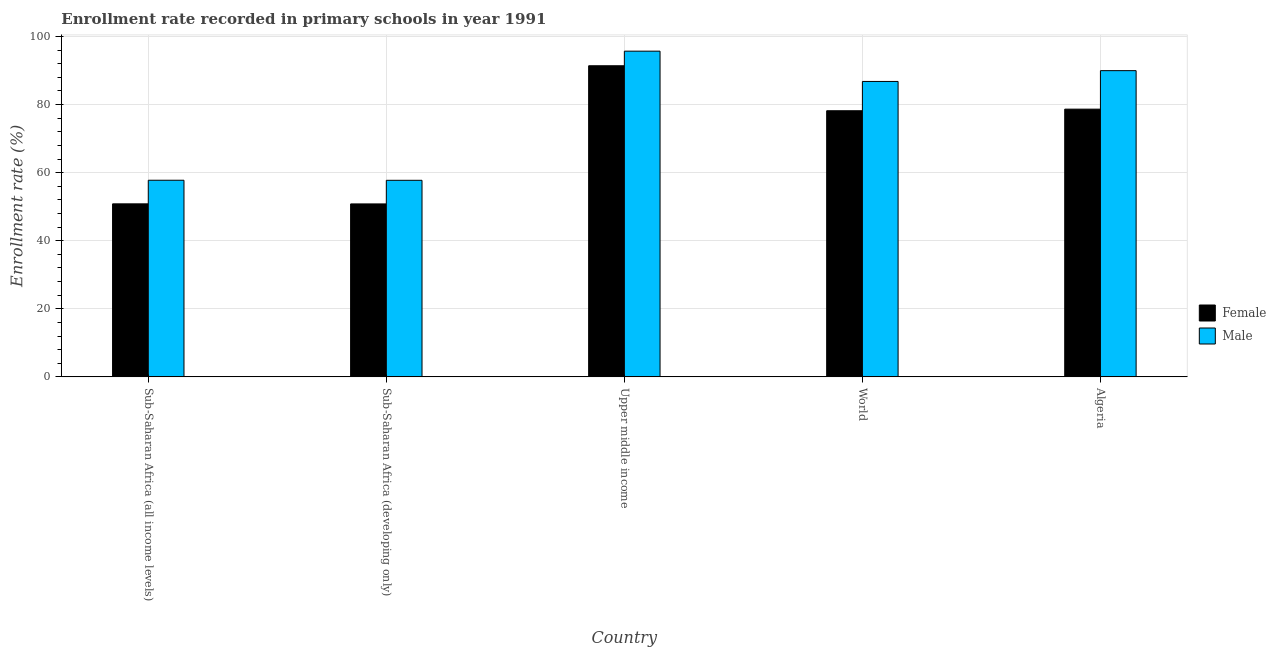How many different coloured bars are there?
Your answer should be compact. 2. Are the number of bars per tick equal to the number of legend labels?
Provide a short and direct response. Yes. Are the number of bars on each tick of the X-axis equal?
Your response must be concise. Yes. How many bars are there on the 4th tick from the left?
Ensure brevity in your answer.  2. What is the enrollment rate of male students in World?
Your answer should be very brief. 86.78. Across all countries, what is the maximum enrollment rate of male students?
Give a very brief answer. 95.68. Across all countries, what is the minimum enrollment rate of male students?
Provide a short and direct response. 57.74. In which country was the enrollment rate of female students maximum?
Offer a terse response. Upper middle income. In which country was the enrollment rate of female students minimum?
Your answer should be compact. Sub-Saharan Africa (developing only). What is the total enrollment rate of male students in the graph?
Offer a terse response. 387.91. What is the difference between the enrollment rate of male students in Algeria and that in Upper middle income?
Keep it short and to the point. -5.73. What is the difference between the enrollment rate of female students in Algeria and the enrollment rate of male students in Upper middle income?
Ensure brevity in your answer.  -17.03. What is the average enrollment rate of male students per country?
Your answer should be very brief. 77.58. What is the difference between the enrollment rate of male students and enrollment rate of female students in Sub-Saharan Africa (all income levels)?
Offer a terse response. 6.93. What is the ratio of the enrollment rate of female students in Algeria to that in Sub-Saharan Africa (all income levels)?
Give a very brief answer. 1.55. Is the enrollment rate of female students in Sub-Saharan Africa (developing only) less than that in World?
Offer a terse response. Yes. What is the difference between the highest and the second highest enrollment rate of female students?
Your answer should be very brief. 12.75. What is the difference between the highest and the lowest enrollment rate of female students?
Ensure brevity in your answer.  40.59. How many bars are there?
Your answer should be very brief. 10. Are all the bars in the graph horizontal?
Ensure brevity in your answer.  No. Does the graph contain any zero values?
Your response must be concise. No. Where does the legend appear in the graph?
Give a very brief answer. Center right. How are the legend labels stacked?
Offer a very short reply. Vertical. What is the title of the graph?
Your response must be concise. Enrollment rate recorded in primary schools in year 1991. Does "Private funds" appear as one of the legend labels in the graph?
Your response must be concise. No. What is the label or title of the Y-axis?
Provide a short and direct response. Enrollment rate (%). What is the Enrollment rate (%) in Female in Sub-Saharan Africa (all income levels)?
Your response must be concise. 50.83. What is the Enrollment rate (%) of Male in Sub-Saharan Africa (all income levels)?
Ensure brevity in your answer.  57.76. What is the Enrollment rate (%) in Female in Sub-Saharan Africa (developing only)?
Offer a terse response. 50.8. What is the Enrollment rate (%) of Male in Sub-Saharan Africa (developing only)?
Offer a very short reply. 57.74. What is the Enrollment rate (%) in Female in Upper middle income?
Ensure brevity in your answer.  91.39. What is the Enrollment rate (%) of Male in Upper middle income?
Your response must be concise. 95.68. What is the Enrollment rate (%) of Female in World?
Your response must be concise. 78.17. What is the Enrollment rate (%) of Male in World?
Your response must be concise. 86.78. What is the Enrollment rate (%) of Female in Algeria?
Your answer should be very brief. 78.64. What is the Enrollment rate (%) in Male in Algeria?
Make the answer very short. 89.95. Across all countries, what is the maximum Enrollment rate (%) of Female?
Your answer should be compact. 91.39. Across all countries, what is the maximum Enrollment rate (%) in Male?
Make the answer very short. 95.68. Across all countries, what is the minimum Enrollment rate (%) in Female?
Ensure brevity in your answer.  50.8. Across all countries, what is the minimum Enrollment rate (%) of Male?
Ensure brevity in your answer.  57.74. What is the total Enrollment rate (%) in Female in the graph?
Provide a succinct answer. 349.84. What is the total Enrollment rate (%) in Male in the graph?
Keep it short and to the point. 387.91. What is the difference between the Enrollment rate (%) of Female in Sub-Saharan Africa (all income levels) and that in Sub-Saharan Africa (developing only)?
Keep it short and to the point. 0.02. What is the difference between the Enrollment rate (%) in Male in Sub-Saharan Africa (all income levels) and that in Sub-Saharan Africa (developing only)?
Your response must be concise. 0.02. What is the difference between the Enrollment rate (%) in Female in Sub-Saharan Africa (all income levels) and that in Upper middle income?
Offer a terse response. -40.57. What is the difference between the Enrollment rate (%) in Male in Sub-Saharan Africa (all income levels) and that in Upper middle income?
Provide a short and direct response. -37.92. What is the difference between the Enrollment rate (%) in Female in Sub-Saharan Africa (all income levels) and that in World?
Provide a succinct answer. -27.35. What is the difference between the Enrollment rate (%) in Male in Sub-Saharan Africa (all income levels) and that in World?
Offer a terse response. -29.02. What is the difference between the Enrollment rate (%) in Female in Sub-Saharan Africa (all income levels) and that in Algeria?
Keep it short and to the point. -27.82. What is the difference between the Enrollment rate (%) of Male in Sub-Saharan Africa (all income levels) and that in Algeria?
Provide a succinct answer. -32.19. What is the difference between the Enrollment rate (%) in Female in Sub-Saharan Africa (developing only) and that in Upper middle income?
Your answer should be very brief. -40.59. What is the difference between the Enrollment rate (%) of Male in Sub-Saharan Africa (developing only) and that in Upper middle income?
Offer a terse response. -37.94. What is the difference between the Enrollment rate (%) of Female in Sub-Saharan Africa (developing only) and that in World?
Your response must be concise. -27.37. What is the difference between the Enrollment rate (%) in Male in Sub-Saharan Africa (developing only) and that in World?
Keep it short and to the point. -29.04. What is the difference between the Enrollment rate (%) of Female in Sub-Saharan Africa (developing only) and that in Algeria?
Your response must be concise. -27.84. What is the difference between the Enrollment rate (%) in Male in Sub-Saharan Africa (developing only) and that in Algeria?
Offer a terse response. -32.21. What is the difference between the Enrollment rate (%) in Female in Upper middle income and that in World?
Keep it short and to the point. 13.22. What is the difference between the Enrollment rate (%) in Male in Upper middle income and that in World?
Your answer should be compact. 8.9. What is the difference between the Enrollment rate (%) of Female in Upper middle income and that in Algeria?
Offer a very short reply. 12.75. What is the difference between the Enrollment rate (%) in Male in Upper middle income and that in Algeria?
Keep it short and to the point. 5.73. What is the difference between the Enrollment rate (%) of Female in World and that in Algeria?
Offer a very short reply. -0.47. What is the difference between the Enrollment rate (%) of Male in World and that in Algeria?
Offer a very short reply. -3.17. What is the difference between the Enrollment rate (%) of Female in Sub-Saharan Africa (all income levels) and the Enrollment rate (%) of Male in Sub-Saharan Africa (developing only)?
Ensure brevity in your answer.  -6.91. What is the difference between the Enrollment rate (%) in Female in Sub-Saharan Africa (all income levels) and the Enrollment rate (%) in Male in Upper middle income?
Make the answer very short. -44.85. What is the difference between the Enrollment rate (%) in Female in Sub-Saharan Africa (all income levels) and the Enrollment rate (%) in Male in World?
Your response must be concise. -35.95. What is the difference between the Enrollment rate (%) in Female in Sub-Saharan Africa (all income levels) and the Enrollment rate (%) in Male in Algeria?
Your answer should be compact. -39.13. What is the difference between the Enrollment rate (%) in Female in Sub-Saharan Africa (developing only) and the Enrollment rate (%) in Male in Upper middle income?
Offer a very short reply. -44.87. What is the difference between the Enrollment rate (%) in Female in Sub-Saharan Africa (developing only) and the Enrollment rate (%) in Male in World?
Offer a very short reply. -35.98. What is the difference between the Enrollment rate (%) of Female in Sub-Saharan Africa (developing only) and the Enrollment rate (%) of Male in Algeria?
Your response must be concise. -39.15. What is the difference between the Enrollment rate (%) of Female in Upper middle income and the Enrollment rate (%) of Male in World?
Offer a very short reply. 4.61. What is the difference between the Enrollment rate (%) of Female in Upper middle income and the Enrollment rate (%) of Male in Algeria?
Your response must be concise. 1.44. What is the difference between the Enrollment rate (%) in Female in World and the Enrollment rate (%) in Male in Algeria?
Your answer should be very brief. -11.78. What is the average Enrollment rate (%) of Female per country?
Keep it short and to the point. 69.97. What is the average Enrollment rate (%) of Male per country?
Make the answer very short. 77.58. What is the difference between the Enrollment rate (%) of Female and Enrollment rate (%) of Male in Sub-Saharan Africa (all income levels)?
Your answer should be compact. -6.93. What is the difference between the Enrollment rate (%) of Female and Enrollment rate (%) of Male in Sub-Saharan Africa (developing only)?
Your answer should be very brief. -6.94. What is the difference between the Enrollment rate (%) of Female and Enrollment rate (%) of Male in Upper middle income?
Make the answer very short. -4.29. What is the difference between the Enrollment rate (%) of Female and Enrollment rate (%) of Male in World?
Make the answer very short. -8.61. What is the difference between the Enrollment rate (%) of Female and Enrollment rate (%) of Male in Algeria?
Provide a short and direct response. -11.31. What is the ratio of the Enrollment rate (%) in Female in Sub-Saharan Africa (all income levels) to that in Upper middle income?
Your answer should be compact. 0.56. What is the ratio of the Enrollment rate (%) in Male in Sub-Saharan Africa (all income levels) to that in Upper middle income?
Offer a very short reply. 0.6. What is the ratio of the Enrollment rate (%) of Female in Sub-Saharan Africa (all income levels) to that in World?
Offer a very short reply. 0.65. What is the ratio of the Enrollment rate (%) of Male in Sub-Saharan Africa (all income levels) to that in World?
Make the answer very short. 0.67. What is the ratio of the Enrollment rate (%) of Female in Sub-Saharan Africa (all income levels) to that in Algeria?
Give a very brief answer. 0.65. What is the ratio of the Enrollment rate (%) of Male in Sub-Saharan Africa (all income levels) to that in Algeria?
Keep it short and to the point. 0.64. What is the ratio of the Enrollment rate (%) of Female in Sub-Saharan Africa (developing only) to that in Upper middle income?
Make the answer very short. 0.56. What is the ratio of the Enrollment rate (%) in Male in Sub-Saharan Africa (developing only) to that in Upper middle income?
Your answer should be compact. 0.6. What is the ratio of the Enrollment rate (%) of Female in Sub-Saharan Africa (developing only) to that in World?
Keep it short and to the point. 0.65. What is the ratio of the Enrollment rate (%) of Male in Sub-Saharan Africa (developing only) to that in World?
Keep it short and to the point. 0.67. What is the ratio of the Enrollment rate (%) in Female in Sub-Saharan Africa (developing only) to that in Algeria?
Your answer should be compact. 0.65. What is the ratio of the Enrollment rate (%) in Male in Sub-Saharan Africa (developing only) to that in Algeria?
Keep it short and to the point. 0.64. What is the ratio of the Enrollment rate (%) of Female in Upper middle income to that in World?
Ensure brevity in your answer.  1.17. What is the ratio of the Enrollment rate (%) in Male in Upper middle income to that in World?
Offer a very short reply. 1.1. What is the ratio of the Enrollment rate (%) in Female in Upper middle income to that in Algeria?
Your answer should be very brief. 1.16. What is the ratio of the Enrollment rate (%) of Male in Upper middle income to that in Algeria?
Ensure brevity in your answer.  1.06. What is the ratio of the Enrollment rate (%) of Female in World to that in Algeria?
Your answer should be compact. 0.99. What is the ratio of the Enrollment rate (%) of Male in World to that in Algeria?
Make the answer very short. 0.96. What is the difference between the highest and the second highest Enrollment rate (%) of Female?
Your response must be concise. 12.75. What is the difference between the highest and the second highest Enrollment rate (%) in Male?
Give a very brief answer. 5.73. What is the difference between the highest and the lowest Enrollment rate (%) of Female?
Your answer should be very brief. 40.59. What is the difference between the highest and the lowest Enrollment rate (%) in Male?
Make the answer very short. 37.94. 